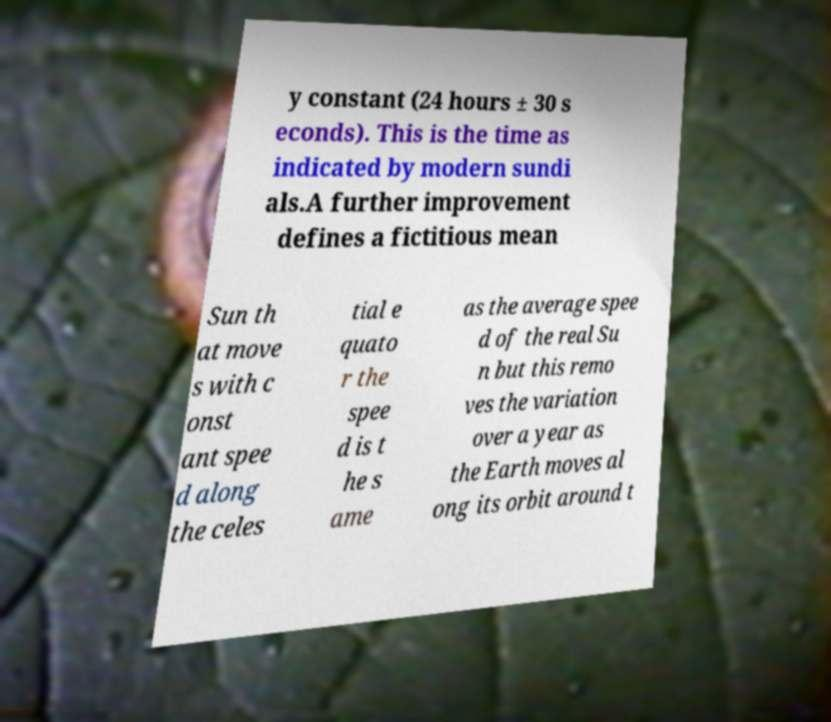Could you extract and type out the text from this image? y constant (24 hours ± 30 s econds). This is the time as indicated by modern sundi als.A further improvement defines a fictitious mean Sun th at move s with c onst ant spee d along the celes tial e quato r the spee d is t he s ame as the average spee d of the real Su n but this remo ves the variation over a year as the Earth moves al ong its orbit around t 